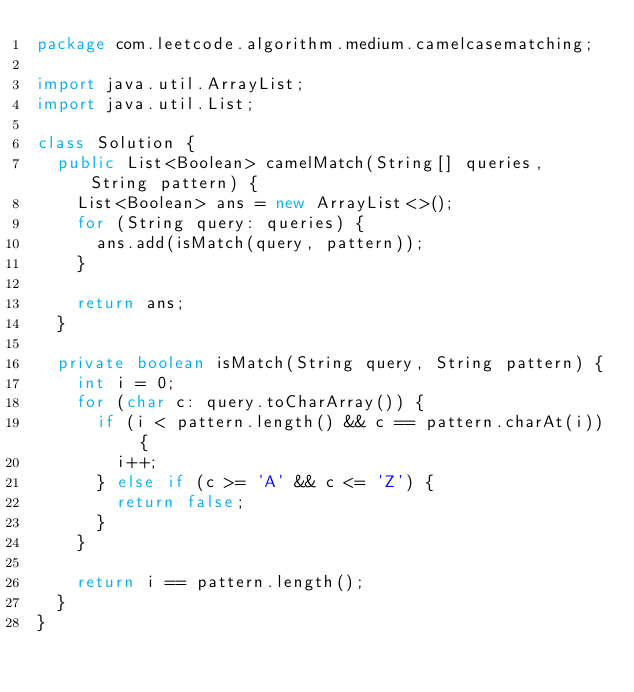<code> <loc_0><loc_0><loc_500><loc_500><_Java_>package com.leetcode.algorithm.medium.camelcasematching;

import java.util.ArrayList;
import java.util.List;

class Solution {
  public List<Boolean> camelMatch(String[] queries, String pattern) {
    List<Boolean> ans = new ArrayList<>();
    for (String query: queries) {
      ans.add(isMatch(query, pattern));
    }

    return ans;
  }

  private boolean isMatch(String query, String pattern) {
    int i = 0;
    for (char c: query.toCharArray()) {
      if (i < pattern.length() && c == pattern.charAt(i)) {
        i++;
      } else if (c >= 'A' && c <= 'Z') {
        return false;
      }
    }

    return i == pattern.length();
  }
}
</code> 